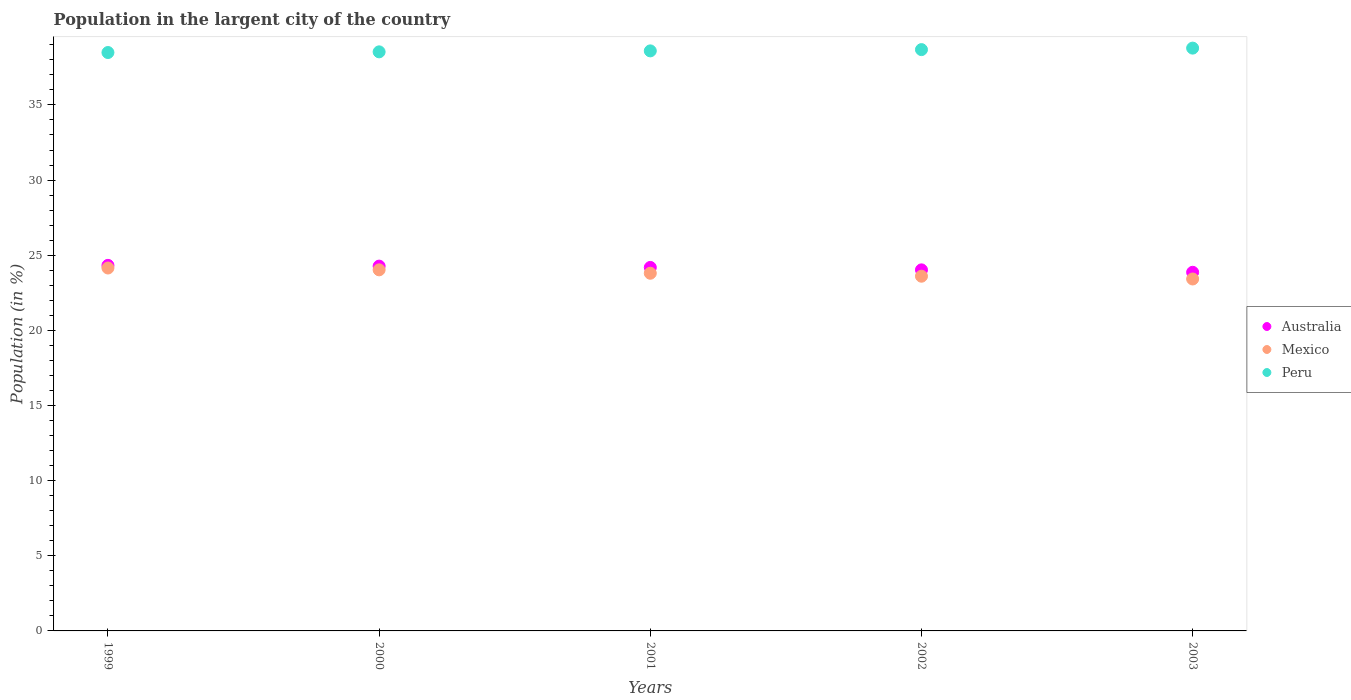How many different coloured dotlines are there?
Make the answer very short. 3. Is the number of dotlines equal to the number of legend labels?
Ensure brevity in your answer.  Yes. What is the percentage of population in the largent city in Australia in 2002?
Provide a short and direct response. 24.02. Across all years, what is the maximum percentage of population in the largent city in Australia?
Offer a terse response. 24.32. Across all years, what is the minimum percentage of population in the largent city in Peru?
Offer a very short reply. 38.49. In which year was the percentage of population in the largent city in Mexico maximum?
Keep it short and to the point. 1999. What is the total percentage of population in the largent city in Mexico in the graph?
Offer a very short reply. 119. What is the difference between the percentage of population in the largent city in Australia in 2000 and that in 2001?
Provide a succinct answer. 0.09. What is the difference between the percentage of population in the largent city in Peru in 2002 and the percentage of population in the largent city in Mexico in 1999?
Make the answer very short. 14.53. What is the average percentage of population in the largent city in Mexico per year?
Give a very brief answer. 23.8. In the year 2001, what is the difference between the percentage of population in the largent city in Australia and percentage of population in the largent city in Mexico?
Your answer should be very brief. 0.39. What is the ratio of the percentage of population in the largent city in Mexico in 2000 to that in 2003?
Provide a short and direct response. 1.03. What is the difference between the highest and the second highest percentage of population in the largent city in Mexico?
Your answer should be very brief. 0.12. What is the difference between the highest and the lowest percentage of population in the largent city in Australia?
Offer a very short reply. 0.46. Does the graph contain grids?
Your answer should be compact. No. Where does the legend appear in the graph?
Give a very brief answer. Center right. How many legend labels are there?
Keep it short and to the point. 3. How are the legend labels stacked?
Offer a very short reply. Vertical. What is the title of the graph?
Make the answer very short. Population in the largent city of the country. Does "Benin" appear as one of the legend labels in the graph?
Provide a short and direct response. No. What is the label or title of the Y-axis?
Your answer should be compact. Population (in %). What is the Population (in %) of Australia in 1999?
Your answer should be very brief. 24.32. What is the Population (in %) in Mexico in 1999?
Your answer should be compact. 24.15. What is the Population (in %) of Peru in 1999?
Your answer should be compact. 38.49. What is the Population (in %) of Australia in 2000?
Offer a terse response. 24.27. What is the Population (in %) of Mexico in 2000?
Provide a short and direct response. 24.03. What is the Population (in %) in Peru in 2000?
Your answer should be very brief. 38.53. What is the Population (in %) in Australia in 2001?
Give a very brief answer. 24.19. What is the Population (in %) in Mexico in 2001?
Provide a succinct answer. 23.8. What is the Population (in %) in Peru in 2001?
Your answer should be very brief. 38.6. What is the Population (in %) in Australia in 2002?
Provide a short and direct response. 24.02. What is the Population (in %) of Mexico in 2002?
Offer a very short reply. 23.6. What is the Population (in %) in Peru in 2002?
Give a very brief answer. 38.68. What is the Population (in %) of Australia in 2003?
Provide a succinct answer. 23.86. What is the Population (in %) in Mexico in 2003?
Offer a terse response. 23.42. What is the Population (in %) of Peru in 2003?
Make the answer very short. 38.78. Across all years, what is the maximum Population (in %) of Australia?
Your answer should be very brief. 24.32. Across all years, what is the maximum Population (in %) in Mexico?
Offer a terse response. 24.15. Across all years, what is the maximum Population (in %) in Peru?
Offer a terse response. 38.78. Across all years, what is the minimum Population (in %) in Australia?
Ensure brevity in your answer.  23.86. Across all years, what is the minimum Population (in %) in Mexico?
Your answer should be very brief. 23.42. Across all years, what is the minimum Population (in %) of Peru?
Offer a terse response. 38.49. What is the total Population (in %) of Australia in the graph?
Make the answer very short. 120.67. What is the total Population (in %) of Mexico in the graph?
Your answer should be very brief. 119. What is the total Population (in %) in Peru in the graph?
Make the answer very short. 193.07. What is the difference between the Population (in %) in Australia in 1999 and that in 2000?
Keep it short and to the point. 0.05. What is the difference between the Population (in %) in Mexico in 1999 and that in 2000?
Make the answer very short. 0.12. What is the difference between the Population (in %) of Peru in 1999 and that in 2000?
Offer a terse response. -0.04. What is the difference between the Population (in %) of Australia in 1999 and that in 2001?
Offer a very short reply. 0.14. What is the difference between the Population (in %) of Mexico in 1999 and that in 2001?
Provide a succinct answer. 0.35. What is the difference between the Population (in %) of Peru in 1999 and that in 2001?
Make the answer very short. -0.11. What is the difference between the Population (in %) of Australia in 1999 and that in 2002?
Offer a terse response. 0.3. What is the difference between the Population (in %) in Mexico in 1999 and that in 2002?
Ensure brevity in your answer.  0.55. What is the difference between the Population (in %) of Peru in 1999 and that in 2002?
Your response must be concise. -0.19. What is the difference between the Population (in %) in Australia in 1999 and that in 2003?
Offer a very short reply. 0.46. What is the difference between the Population (in %) of Mexico in 1999 and that in 2003?
Offer a terse response. 0.73. What is the difference between the Population (in %) in Peru in 1999 and that in 2003?
Offer a very short reply. -0.29. What is the difference between the Population (in %) of Australia in 2000 and that in 2001?
Offer a terse response. 0.09. What is the difference between the Population (in %) in Mexico in 2000 and that in 2001?
Offer a very short reply. 0.23. What is the difference between the Population (in %) in Peru in 2000 and that in 2001?
Your response must be concise. -0.06. What is the difference between the Population (in %) in Australia in 2000 and that in 2002?
Provide a short and direct response. 0.25. What is the difference between the Population (in %) in Mexico in 2000 and that in 2002?
Offer a terse response. 0.42. What is the difference between the Population (in %) of Peru in 2000 and that in 2002?
Your answer should be very brief. -0.15. What is the difference between the Population (in %) in Australia in 2000 and that in 2003?
Make the answer very short. 0.41. What is the difference between the Population (in %) in Mexico in 2000 and that in 2003?
Your answer should be very brief. 0.61. What is the difference between the Population (in %) in Peru in 2000 and that in 2003?
Give a very brief answer. -0.25. What is the difference between the Population (in %) of Australia in 2001 and that in 2002?
Offer a very short reply. 0.16. What is the difference between the Population (in %) of Mexico in 2001 and that in 2002?
Your answer should be compact. 0.2. What is the difference between the Population (in %) of Peru in 2001 and that in 2002?
Provide a succinct answer. -0.08. What is the difference between the Population (in %) in Australia in 2001 and that in 2003?
Ensure brevity in your answer.  0.32. What is the difference between the Population (in %) of Mexico in 2001 and that in 2003?
Offer a terse response. 0.38. What is the difference between the Population (in %) in Peru in 2001 and that in 2003?
Provide a succinct answer. -0.18. What is the difference between the Population (in %) of Australia in 2002 and that in 2003?
Provide a short and direct response. 0.16. What is the difference between the Population (in %) in Mexico in 2002 and that in 2003?
Your answer should be compact. 0.18. What is the difference between the Population (in %) of Peru in 2002 and that in 2003?
Your answer should be compact. -0.1. What is the difference between the Population (in %) in Australia in 1999 and the Population (in %) in Mexico in 2000?
Your answer should be compact. 0.3. What is the difference between the Population (in %) in Australia in 1999 and the Population (in %) in Peru in 2000?
Your answer should be very brief. -14.21. What is the difference between the Population (in %) in Mexico in 1999 and the Population (in %) in Peru in 2000?
Your answer should be compact. -14.38. What is the difference between the Population (in %) in Australia in 1999 and the Population (in %) in Mexico in 2001?
Keep it short and to the point. 0.52. What is the difference between the Population (in %) in Australia in 1999 and the Population (in %) in Peru in 2001?
Provide a short and direct response. -14.27. What is the difference between the Population (in %) of Mexico in 1999 and the Population (in %) of Peru in 2001?
Make the answer very short. -14.45. What is the difference between the Population (in %) of Australia in 1999 and the Population (in %) of Mexico in 2002?
Offer a very short reply. 0.72. What is the difference between the Population (in %) of Australia in 1999 and the Population (in %) of Peru in 2002?
Ensure brevity in your answer.  -14.36. What is the difference between the Population (in %) of Mexico in 1999 and the Population (in %) of Peru in 2002?
Your answer should be very brief. -14.53. What is the difference between the Population (in %) in Australia in 1999 and the Population (in %) in Mexico in 2003?
Offer a very short reply. 0.91. What is the difference between the Population (in %) of Australia in 1999 and the Population (in %) of Peru in 2003?
Offer a very short reply. -14.46. What is the difference between the Population (in %) of Mexico in 1999 and the Population (in %) of Peru in 2003?
Offer a very short reply. -14.63. What is the difference between the Population (in %) in Australia in 2000 and the Population (in %) in Mexico in 2001?
Provide a short and direct response. 0.47. What is the difference between the Population (in %) of Australia in 2000 and the Population (in %) of Peru in 2001?
Your response must be concise. -14.32. What is the difference between the Population (in %) in Mexico in 2000 and the Population (in %) in Peru in 2001?
Offer a terse response. -14.57. What is the difference between the Population (in %) of Australia in 2000 and the Population (in %) of Mexico in 2002?
Offer a terse response. 0.67. What is the difference between the Population (in %) in Australia in 2000 and the Population (in %) in Peru in 2002?
Give a very brief answer. -14.41. What is the difference between the Population (in %) in Mexico in 2000 and the Population (in %) in Peru in 2002?
Your answer should be very brief. -14.65. What is the difference between the Population (in %) of Australia in 2000 and the Population (in %) of Mexico in 2003?
Offer a terse response. 0.86. What is the difference between the Population (in %) of Australia in 2000 and the Population (in %) of Peru in 2003?
Keep it short and to the point. -14.51. What is the difference between the Population (in %) in Mexico in 2000 and the Population (in %) in Peru in 2003?
Ensure brevity in your answer.  -14.75. What is the difference between the Population (in %) in Australia in 2001 and the Population (in %) in Mexico in 2002?
Your answer should be very brief. 0.58. What is the difference between the Population (in %) of Australia in 2001 and the Population (in %) of Peru in 2002?
Your answer should be compact. -14.49. What is the difference between the Population (in %) of Mexico in 2001 and the Population (in %) of Peru in 2002?
Provide a succinct answer. -14.88. What is the difference between the Population (in %) in Australia in 2001 and the Population (in %) in Mexico in 2003?
Give a very brief answer. 0.77. What is the difference between the Population (in %) of Australia in 2001 and the Population (in %) of Peru in 2003?
Provide a succinct answer. -14.59. What is the difference between the Population (in %) in Mexico in 2001 and the Population (in %) in Peru in 2003?
Your answer should be very brief. -14.98. What is the difference between the Population (in %) of Australia in 2002 and the Population (in %) of Mexico in 2003?
Give a very brief answer. 0.61. What is the difference between the Population (in %) in Australia in 2002 and the Population (in %) in Peru in 2003?
Keep it short and to the point. -14.76. What is the difference between the Population (in %) in Mexico in 2002 and the Population (in %) in Peru in 2003?
Make the answer very short. -15.18. What is the average Population (in %) in Australia per year?
Provide a short and direct response. 24.13. What is the average Population (in %) in Mexico per year?
Keep it short and to the point. 23.8. What is the average Population (in %) in Peru per year?
Your answer should be very brief. 38.61. In the year 1999, what is the difference between the Population (in %) in Australia and Population (in %) in Mexico?
Your response must be concise. 0.18. In the year 1999, what is the difference between the Population (in %) in Australia and Population (in %) in Peru?
Keep it short and to the point. -14.16. In the year 1999, what is the difference between the Population (in %) of Mexico and Population (in %) of Peru?
Your answer should be very brief. -14.34. In the year 2000, what is the difference between the Population (in %) of Australia and Population (in %) of Mexico?
Your response must be concise. 0.25. In the year 2000, what is the difference between the Population (in %) of Australia and Population (in %) of Peru?
Your answer should be compact. -14.26. In the year 2000, what is the difference between the Population (in %) of Mexico and Population (in %) of Peru?
Your answer should be compact. -14.51. In the year 2001, what is the difference between the Population (in %) of Australia and Population (in %) of Mexico?
Offer a terse response. 0.39. In the year 2001, what is the difference between the Population (in %) in Australia and Population (in %) in Peru?
Provide a short and direct response. -14.41. In the year 2001, what is the difference between the Population (in %) of Mexico and Population (in %) of Peru?
Keep it short and to the point. -14.8. In the year 2002, what is the difference between the Population (in %) in Australia and Population (in %) in Mexico?
Give a very brief answer. 0.42. In the year 2002, what is the difference between the Population (in %) in Australia and Population (in %) in Peru?
Give a very brief answer. -14.66. In the year 2002, what is the difference between the Population (in %) of Mexico and Population (in %) of Peru?
Your response must be concise. -15.08. In the year 2003, what is the difference between the Population (in %) in Australia and Population (in %) in Mexico?
Keep it short and to the point. 0.45. In the year 2003, what is the difference between the Population (in %) in Australia and Population (in %) in Peru?
Give a very brief answer. -14.92. In the year 2003, what is the difference between the Population (in %) in Mexico and Population (in %) in Peru?
Make the answer very short. -15.36. What is the ratio of the Population (in %) of Australia in 1999 to that in 2000?
Make the answer very short. 1. What is the ratio of the Population (in %) of Mexico in 1999 to that in 2001?
Offer a very short reply. 1.01. What is the ratio of the Population (in %) of Australia in 1999 to that in 2002?
Provide a succinct answer. 1.01. What is the ratio of the Population (in %) of Mexico in 1999 to that in 2002?
Give a very brief answer. 1.02. What is the ratio of the Population (in %) of Peru in 1999 to that in 2002?
Offer a very short reply. 0.99. What is the ratio of the Population (in %) in Australia in 1999 to that in 2003?
Keep it short and to the point. 1.02. What is the ratio of the Population (in %) in Mexico in 1999 to that in 2003?
Your answer should be very brief. 1.03. What is the ratio of the Population (in %) of Mexico in 2000 to that in 2001?
Provide a short and direct response. 1.01. What is the ratio of the Population (in %) in Australia in 2000 to that in 2002?
Make the answer very short. 1.01. What is the ratio of the Population (in %) in Peru in 2000 to that in 2002?
Ensure brevity in your answer.  1. What is the ratio of the Population (in %) of Australia in 2000 to that in 2003?
Provide a short and direct response. 1.02. What is the ratio of the Population (in %) of Mexico in 2000 to that in 2003?
Give a very brief answer. 1.03. What is the ratio of the Population (in %) in Peru in 2000 to that in 2003?
Your response must be concise. 0.99. What is the ratio of the Population (in %) of Australia in 2001 to that in 2002?
Make the answer very short. 1.01. What is the ratio of the Population (in %) in Mexico in 2001 to that in 2002?
Offer a very short reply. 1.01. What is the ratio of the Population (in %) in Peru in 2001 to that in 2002?
Keep it short and to the point. 1. What is the ratio of the Population (in %) in Australia in 2001 to that in 2003?
Give a very brief answer. 1.01. What is the ratio of the Population (in %) in Mexico in 2001 to that in 2003?
Give a very brief answer. 1.02. What is the ratio of the Population (in %) in Peru in 2001 to that in 2003?
Your answer should be very brief. 1. What is the ratio of the Population (in %) of Australia in 2002 to that in 2003?
Give a very brief answer. 1.01. What is the ratio of the Population (in %) of Mexico in 2002 to that in 2003?
Offer a terse response. 1.01. What is the difference between the highest and the second highest Population (in %) of Australia?
Offer a very short reply. 0.05. What is the difference between the highest and the second highest Population (in %) of Mexico?
Your answer should be compact. 0.12. What is the difference between the highest and the second highest Population (in %) of Peru?
Your response must be concise. 0.1. What is the difference between the highest and the lowest Population (in %) of Australia?
Your answer should be compact. 0.46. What is the difference between the highest and the lowest Population (in %) in Mexico?
Give a very brief answer. 0.73. What is the difference between the highest and the lowest Population (in %) of Peru?
Keep it short and to the point. 0.29. 